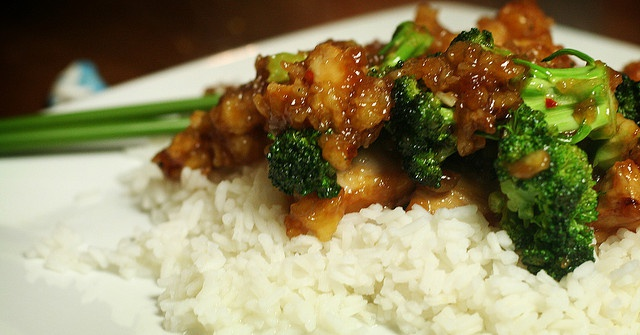Describe the objects in this image and their specific colors. I can see broccoli in black, maroon, and olive tones, broccoli in black, darkgreen, and olive tones, broccoli in black, darkgreen, and maroon tones, broccoli in black, darkgreen, and maroon tones, and broccoli in black and olive tones in this image. 